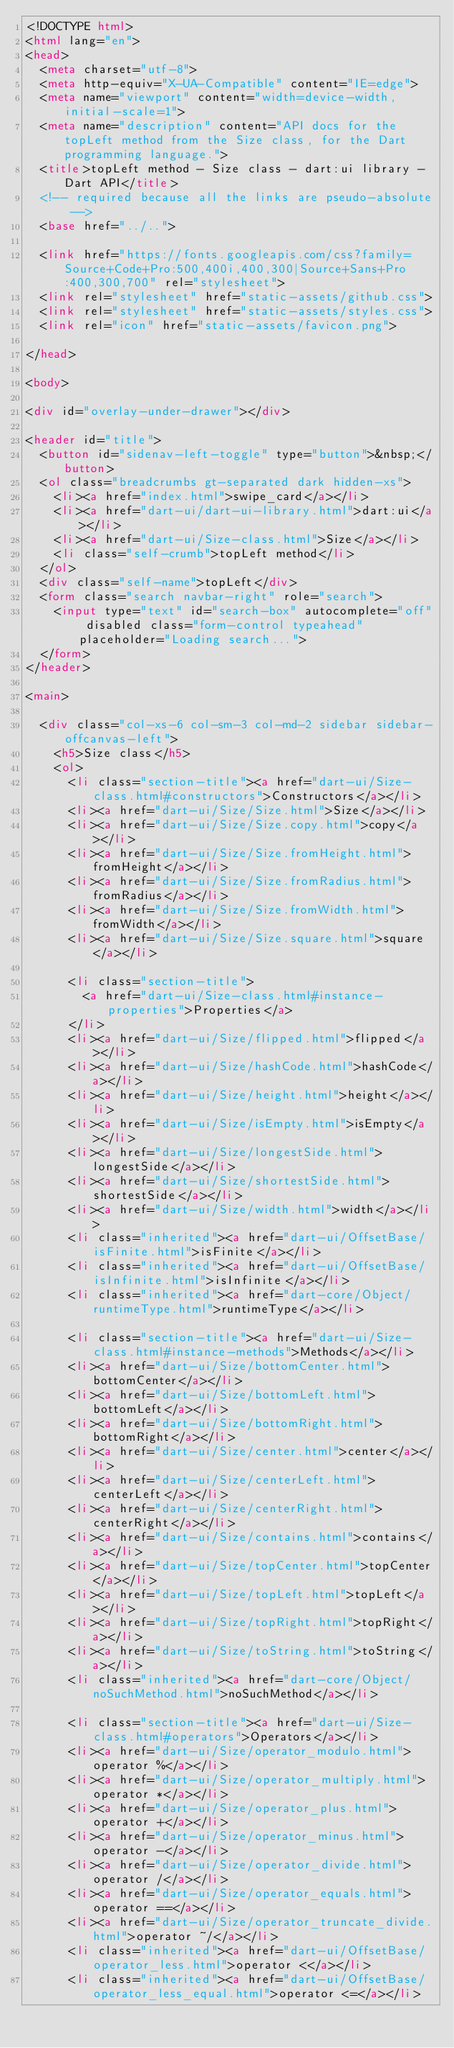Convert code to text. <code><loc_0><loc_0><loc_500><loc_500><_HTML_><!DOCTYPE html>
<html lang="en">
<head>
  <meta charset="utf-8">
  <meta http-equiv="X-UA-Compatible" content="IE=edge">
  <meta name="viewport" content="width=device-width, initial-scale=1">
  <meta name="description" content="API docs for the topLeft method from the Size class, for the Dart programming language.">
  <title>topLeft method - Size class - dart:ui library - Dart API</title>
  <!-- required because all the links are pseudo-absolute -->
  <base href="../..">

  <link href="https://fonts.googleapis.com/css?family=Source+Code+Pro:500,400i,400,300|Source+Sans+Pro:400,300,700" rel="stylesheet">
  <link rel="stylesheet" href="static-assets/github.css">
  <link rel="stylesheet" href="static-assets/styles.css">
  <link rel="icon" href="static-assets/favicon.png">

</head>

<body>

<div id="overlay-under-drawer"></div>

<header id="title">
  <button id="sidenav-left-toggle" type="button">&nbsp;</button>
  <ol class="breadcrumbs gt-separated dark hidden-xs">
    <li><a href="index.html">swipe_card</a></li>
    <li><a href="dart-ui/dart-ui-library.html">dart:ui</a></li>
    <li><a href="dart-ui/Size-class.html">Size</a></li>
    <li class="self-crumb">topLeft method</li>
  </ol>
  <div class="self-name">topLeft</div>
  <form class="search navbar-right" role="search">
    <input type="text" id="search-box" autocomplete="off" disabled class="form-control typeahead" placeholder="Loading search...">
  </form>
</header>

<main>

  <div class="col-xs-6 col-sm-3 col-md-2 sidebar sidebar-offcanvas-left">
    <h5>Size class</h5>
    <ol>
      <li class="section-title"><a href="dart-ui/Size-class.html#constructors">Constructors</a></li>
      <li><a href="dart-ui/Size/Size.html">Size</a></li>
      <li><a href="dart-ui/Size/Size.copy.html">copy</a></li>
      <li><a href="dart-ui/Size/Size.fromHeight.html">fromHeight</a></li>
      <li><a href="dart-ui/Size/Size.fromRadius.html">fromRadius</a></li>
      <li><a href="dart-ui/Size/Size.fromWidth.html">fromWidth</a></li>
      <li><a href="dart-ui/Size/Size.square.html">square</a></li>
    
      <li class="section-title">
        <a href="dart-ui/Size-class.html#instance-properties">Properties</a>
      </li>
      <li><a href="dart-ui/Size/flipped.html">flipped</a></li>
      <li><a href="dart-ui/Size/hashCode.html">hashCode</a></li>
      <li><a href="dart-ui/Size/height.html">height</a></li>
      <li><a href="dart-ui/Size/isEmpty.html">isEmpty</a></li>
      <li><a href="dart-ui/Size/longestSide.html">longestSide</a></li>
      <li><a href="dart-ui/Size/shortestSide.html">shortestSide</a></li>
      <li><a href="dart-ui/Size/width.html">width</a></li>
      <li class="inherited"><a href="dart-ui/OffsetBase/isFinite.html">isFinite</a></li>
      <li class="inherited"><a href="dart-ui/OffsetBase/isInfinite.html">isInfinite</a></li>
      <li class="inherited"><a href="dart-core/Object/runtimeType.html">runtimeType</a></li>
    
      <li class="section-title"><a href="dart-ui/Size-class.html#instance-methods">Methods</a></li>
      <li><a href="dart-ui/Size/bottomCenter.html">bottomCenter</a></li>
      <li><a href="dart-ui/Size/bottomLeft.html">bottomLeft</a></li>
      <li><a href="dart-ui/Size/bottomRight.html">bottomRight</a></li>
      <li><a href="dart-ui/Size/center.html">center</a></li>
      <li><a href="dart-ui/Size/centerLeft.html">centerLeft</a></li>
      <li><a href="dart-ui/Size/centerRight.html">centerRight</a></li>
      <li><a href="dart-ui/Size/contains.html">contains</a></li>
      <li><a href="dart-ui/Size/topCenter.html">topCenter</a></li>
      <li><a href="dart-ui/Size/topLeft.html">topLeft</a></li>
      <li><a href="dart-ui/Size/topRight.html">topRight</a></li>
      <li><a href="dart-ui/Size/toString.html">toString</a></li>
      <li class="inherited"><a href="dart-core/Object/noSuchMethod.html">noSuchMethod</a></li>
    
      <li class="section-title"><a href="dart-ui/Size-class.html#operators">Operators</a></li>
      <li><a href="dart-ui/Size/operator_modulo.html">operator %</a></li>
      <li><a href="dart-ui/Size/operator_multiply.html">operator *</a></li>
      <li><a href="dart-ui/Size/operator_plus.html">operator +</a></li>
      <li><a href="dart-ui/Size/operator_minus.html">operator -</a></li>
      <li><a href="dart-ui/Size/operator_divide.html">operator /</a></li>
      <li><a href="dart-ui/Size/operator_equals.html">operator ==</a></li>
      <li><a href="dart-ui/Size/operator_truncate_divide.html">operator ~/</a></li>
      <li class="inherited"><a href="dart-ui/OffsetBase/operator_less.html">operator <</a></li>
      <li class="inherited"><a href="dart-ui/OffsetBase/operator_less_equal.html">operator <=</a></li></code> 